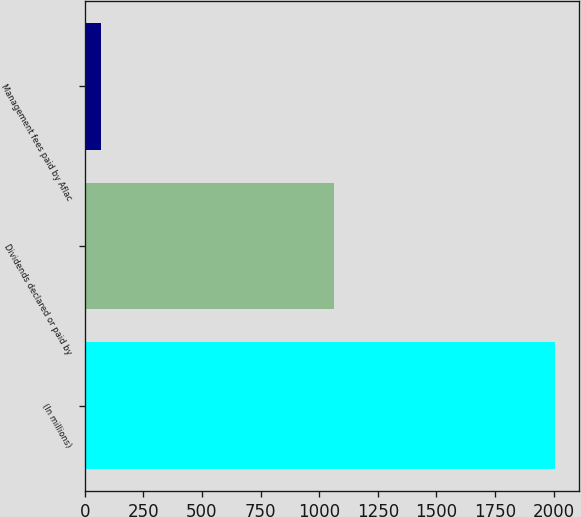Convert chart. <chart><loc_0><loc_0><loc_500><loc_500><bar_chart><fcel>(In millions)<fcel>Dividends declared or paid by<fcel>Management fees paid by Aflac<nl><fcel>2008<fcel>1062<fcel>71<nl></chart> 